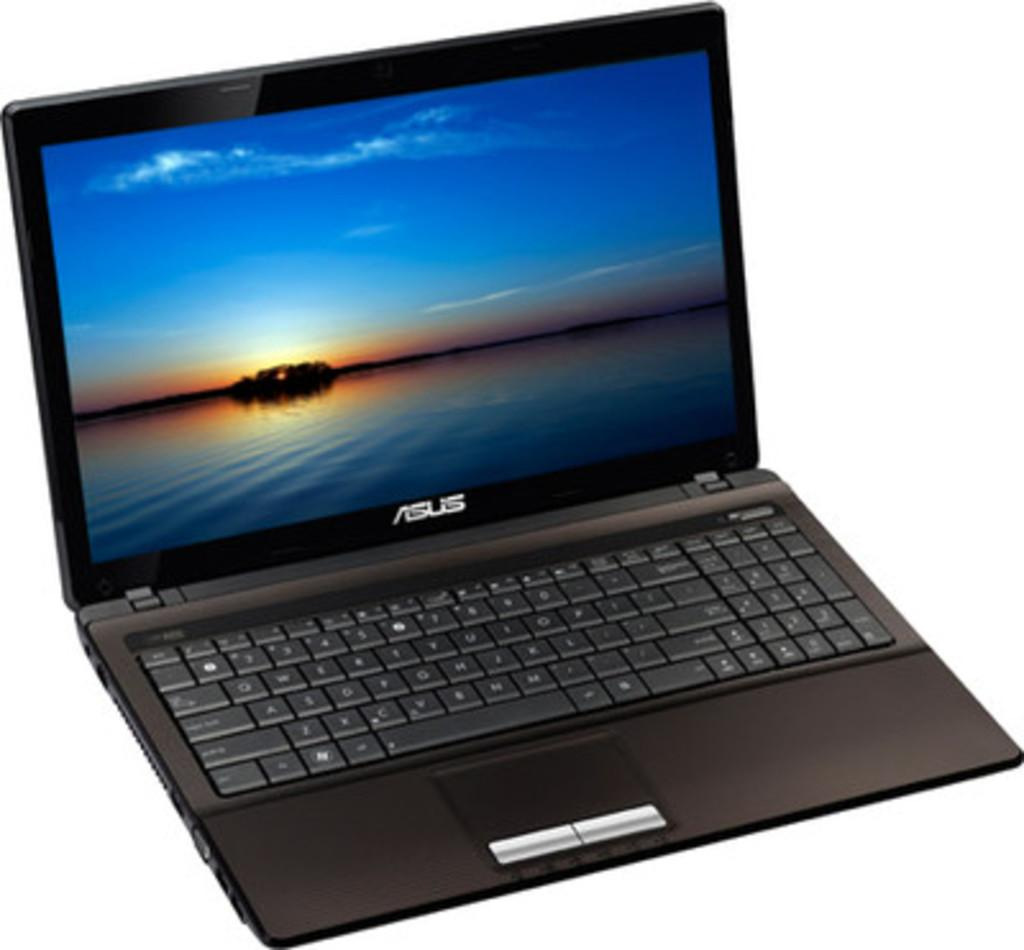<image>
Render a clear and concise summary of the photo. A shopping photo of an Asus laptop with its background showing a body of water. 